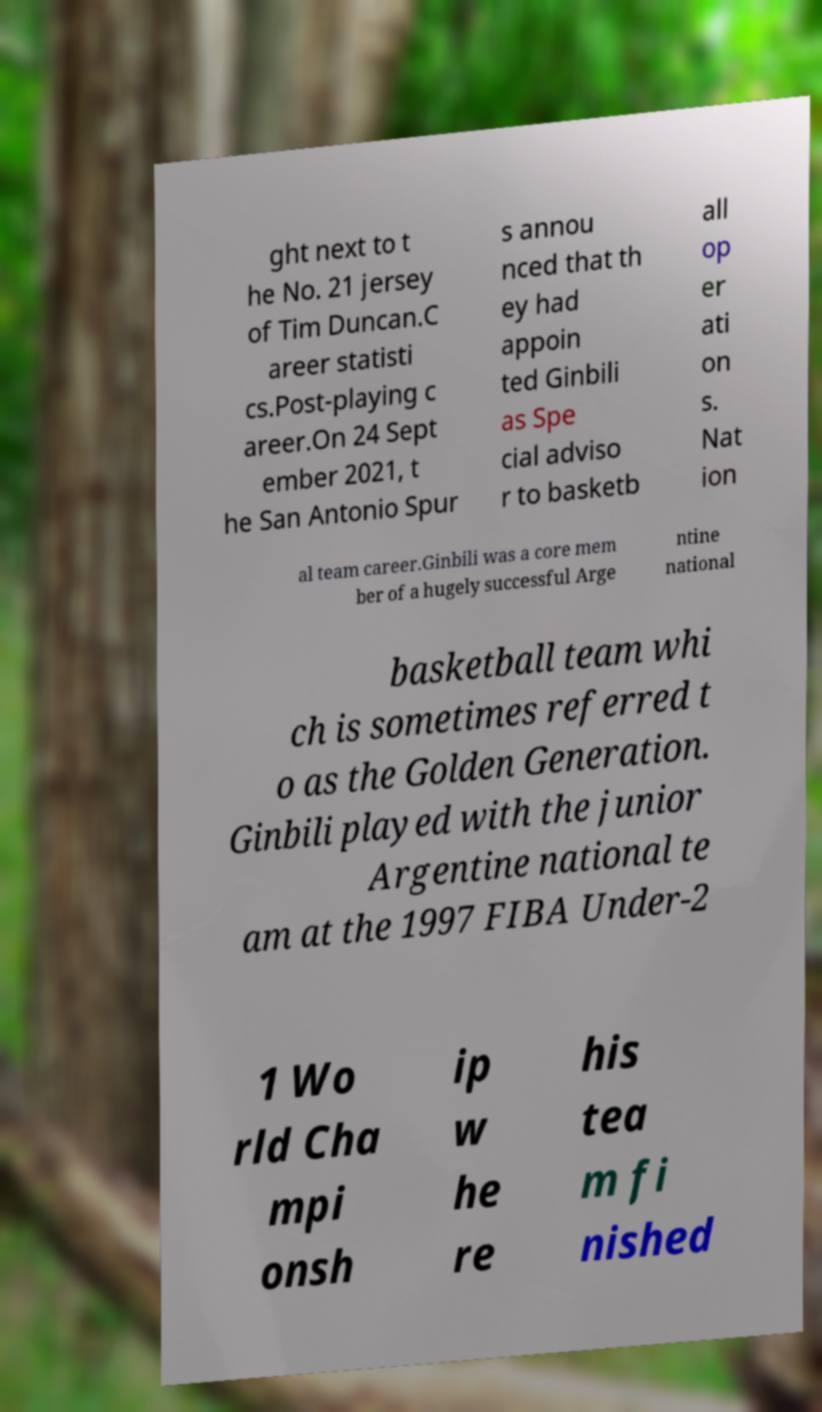Please identify and transcribe the text found in this image. ght next to t he No. 21 jersey of Tim Duncan.C areer statisti cs.Post-playing c areer.On 24 Sept ember 2021, t he San Antonio Spur s annou nced that th ey had appoin ted Ginbili as Spe cial adviso r to basketb all op er ati on s. Nat ion al team career.Ginbili was a core mem ber of a hugely successful Arge ntine national basketball team whi ch is sometimes referred t o as the Golden Generation. Ginbili played with the junior Argentine national te am at the 1997 FIBA Under-2 1 Wo rld Cha mpi onsh ip w he re his tea m fi nished 